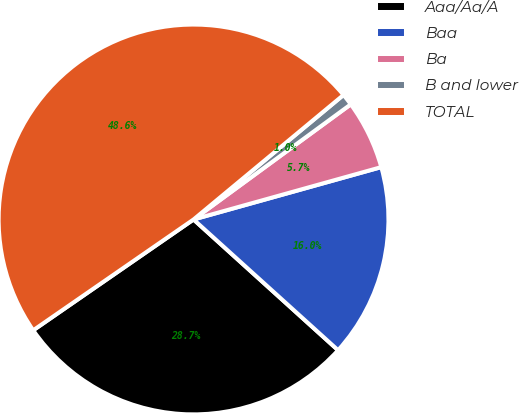Convert chart to OTSL. <chart><loc_0><loc_0><loc_500><loc_500><pie_chart><fcel>Aaa/Aa/A<fcel>Baa<fcel>Ba<fcel>B and lower<fcel>TOTAL<nl><fcel>28.67%<fcel>16.03%<fcel>5.73%<fcel>0.97%<fcel>48.59%<nl></chart> 